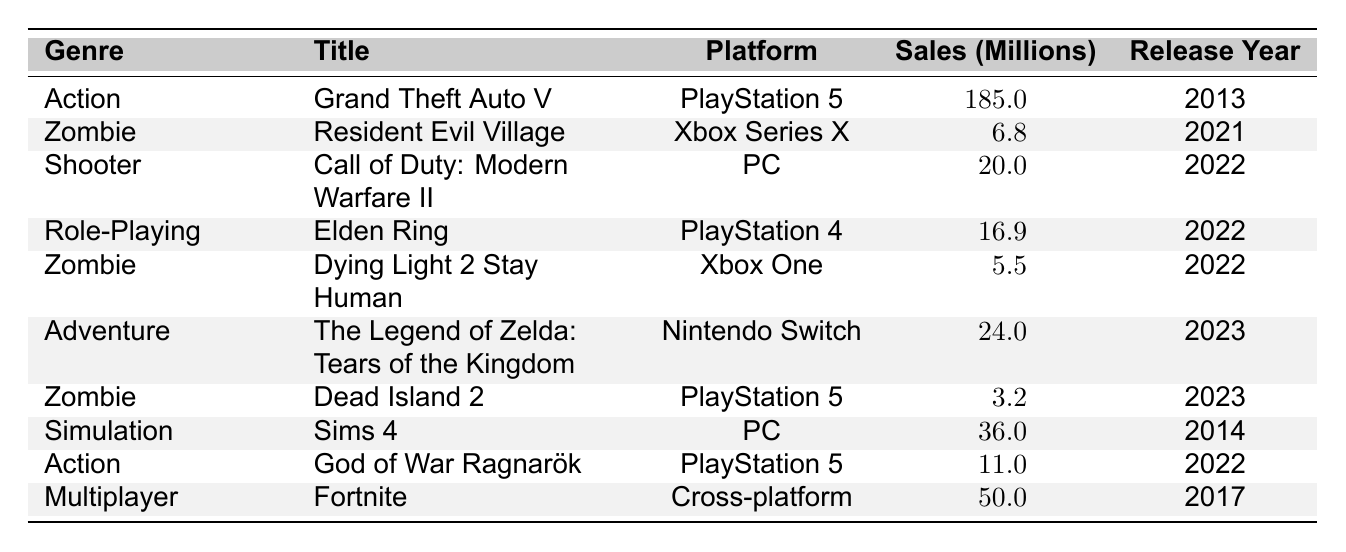What is the highest-selling game in 2023? The table shows that "The Legend of Zelda: Tears of the Kingdom," with sales of 24 million, is listed as being released in 2023. It is the only game from that year in the table, making it the highest-selling game for 2023.
Answer: 24 million How many Zombie genre games are listed in the table? Three games are classified under the Zombie genre: "Resident Evil Village," "Dying Light 2 Stay Human," and "Dead Island 2." Counting these gives a total of three games in this genre.
Answer: 3 What is the total sales in millions for all games in the Action genre? The total for Action genre games consists of "Grand Theft Auto V" (185 million) and "God of War Ragnarök" (11 million). Adding these amounts gives 185 + 11 = 196 million.
Answer: 196 million What is the difference in sales between the best-selling game and the least-selling Zombie game? The best-selling Zombie game is "Resident Evil Village" with 6.8 million, and the least-selling is "Dead Island 2" with 3.2 million. The difference is calculated as 6.8 - 3.2 = 3.6 million.
Answer: 3.6 million Is "Dying Light 2 Stay Human" the only Zombie game released in 2022? The table lists two Zombie games for the year 2022: "Dying Light 2 Stay Human" and "Resident Evil Village." Therefore, "Dying Light 2 Stay Human" is not the only one released in that year.
Answer: No What is the average sales for games in the Simulation genre? There is only one Simulation game, "Sims 4," with sales of 36 million. Since there is only one data point, the average is the same as its sales: 36 million.
Answer: 36 million Which genre has the highest total sales when games are summed up? Summing the sales yields: Action (196 million), Zombie (15.5 million), Shooter (20 million), Role-Playing (16.9 million), Adventure (24 million), Simulation (36 million), and Multiplayer (50 million). The highest total sales come from the Action genre with 196 million.
Answer: Action What platform has the game with the lowest sales and what is the game? The game with the lowest sales is "Dead Island 2," which is on the PlayStation 5 with sales of 3.2 million.
Answer: PlayStation 5, Dead Island 2 Are there more Action games than Zombie games listed in total? There are two Action games ("Grand Theft Auto V" and "God of War Ragnarök") and three Zombie games ("Resident Evil Village," "Dying Light 2 Stay Human," and "Dead Island 2"). Therefore, there are fewer Action games than Zombie games.
Answer: No How many different platforms are represented in the table? The platforms listed are PlayStation 5, Xbox Series X, PC, PlayStation 4, Xbox One, Nintendo Switch, and Cross-platform. Counting these gives a total of seven different platforms.
Answer: 7 